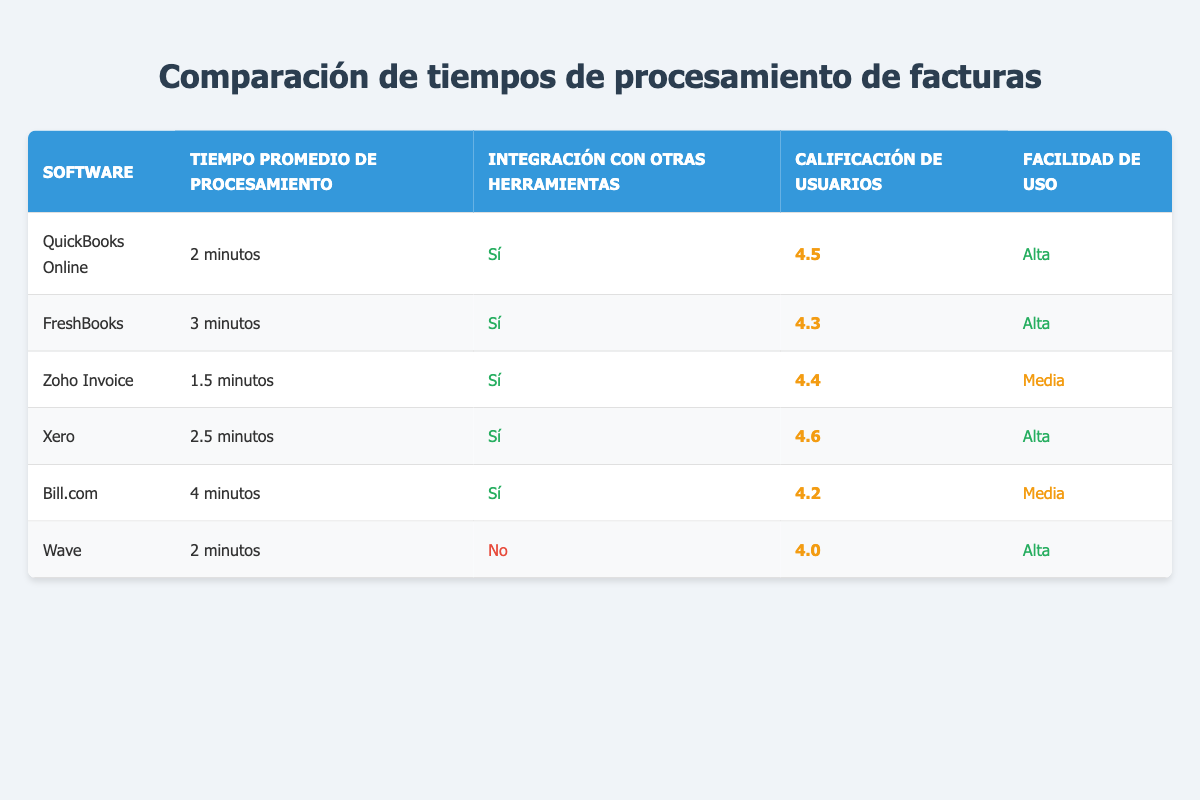What is the average processing time for an invoice using Zoho Invoice? The table lists the average processing time for Zoho Invoice as 1.5 minutes.
Answer: 1.5 minutes Which software has the highest user rating? According to the table, Xero has the highest user rating at 4.6.
Answer: Xero How many software solutions have a high ease of use rating? The table indicates that QuickBooks Online, FreshBooks, Xero, and Wave all have a "high" ease of use rating, totaling four software solutions.
Answer: 4 Is there a software that does not integrate with other tools? The table shows that Wave is the only software that does not integrate with other tools, as indicated in the integration column.
Answer: Yes What is the difference in average processing times between QuickBooks Online and Bill.com? QuickBooks Online has an average processing time of 2 minutes and Bill.com has 4 minutes. The difference is calculated as 4 minutes - 2 minutes = 2 minutes.
Answer: 2 minutes Which software solution has the longest average processing time for invoices? The longest processing time in the table is Bill.com with an average of 4 minutes.
Answer: Bill.com What is the user rating of FreshBooks? The table lists FreshBooks’ user rating as 4.3.
Answer: 4.3 If we rank the software by average processing time, what would be the second fastest? The table shows Zoho Invoice as the fastest at 1.5 minutes, followed by QuickBooks Online at 2 minutes, making it the second fastest when ranked by processing time.
Answer: QuickBooks Online Are there any software solutions with a medium ease of use rating? Yes, both Zoho Invoice and Bill.com are indicated in the table as having a medium ease of use rating.
Answer: Yes 